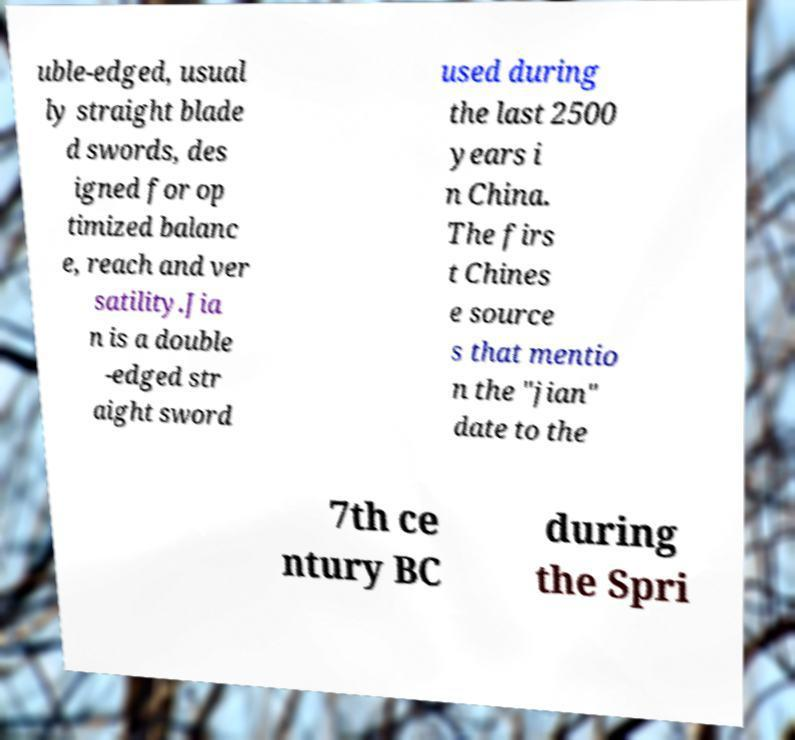There's text embedded in this image that I need extracted. Can you transcribe it verbatim? uble-edged, usual ly straight blade d swords, des igned for op timized balanc e, reach and ver satility.Jia n is a double -edged str aight sword used during the last 2500 years i n China. The firs t Chines e source s that mentio n the "jian" date to the 7th ce ntury BC during the Spri 